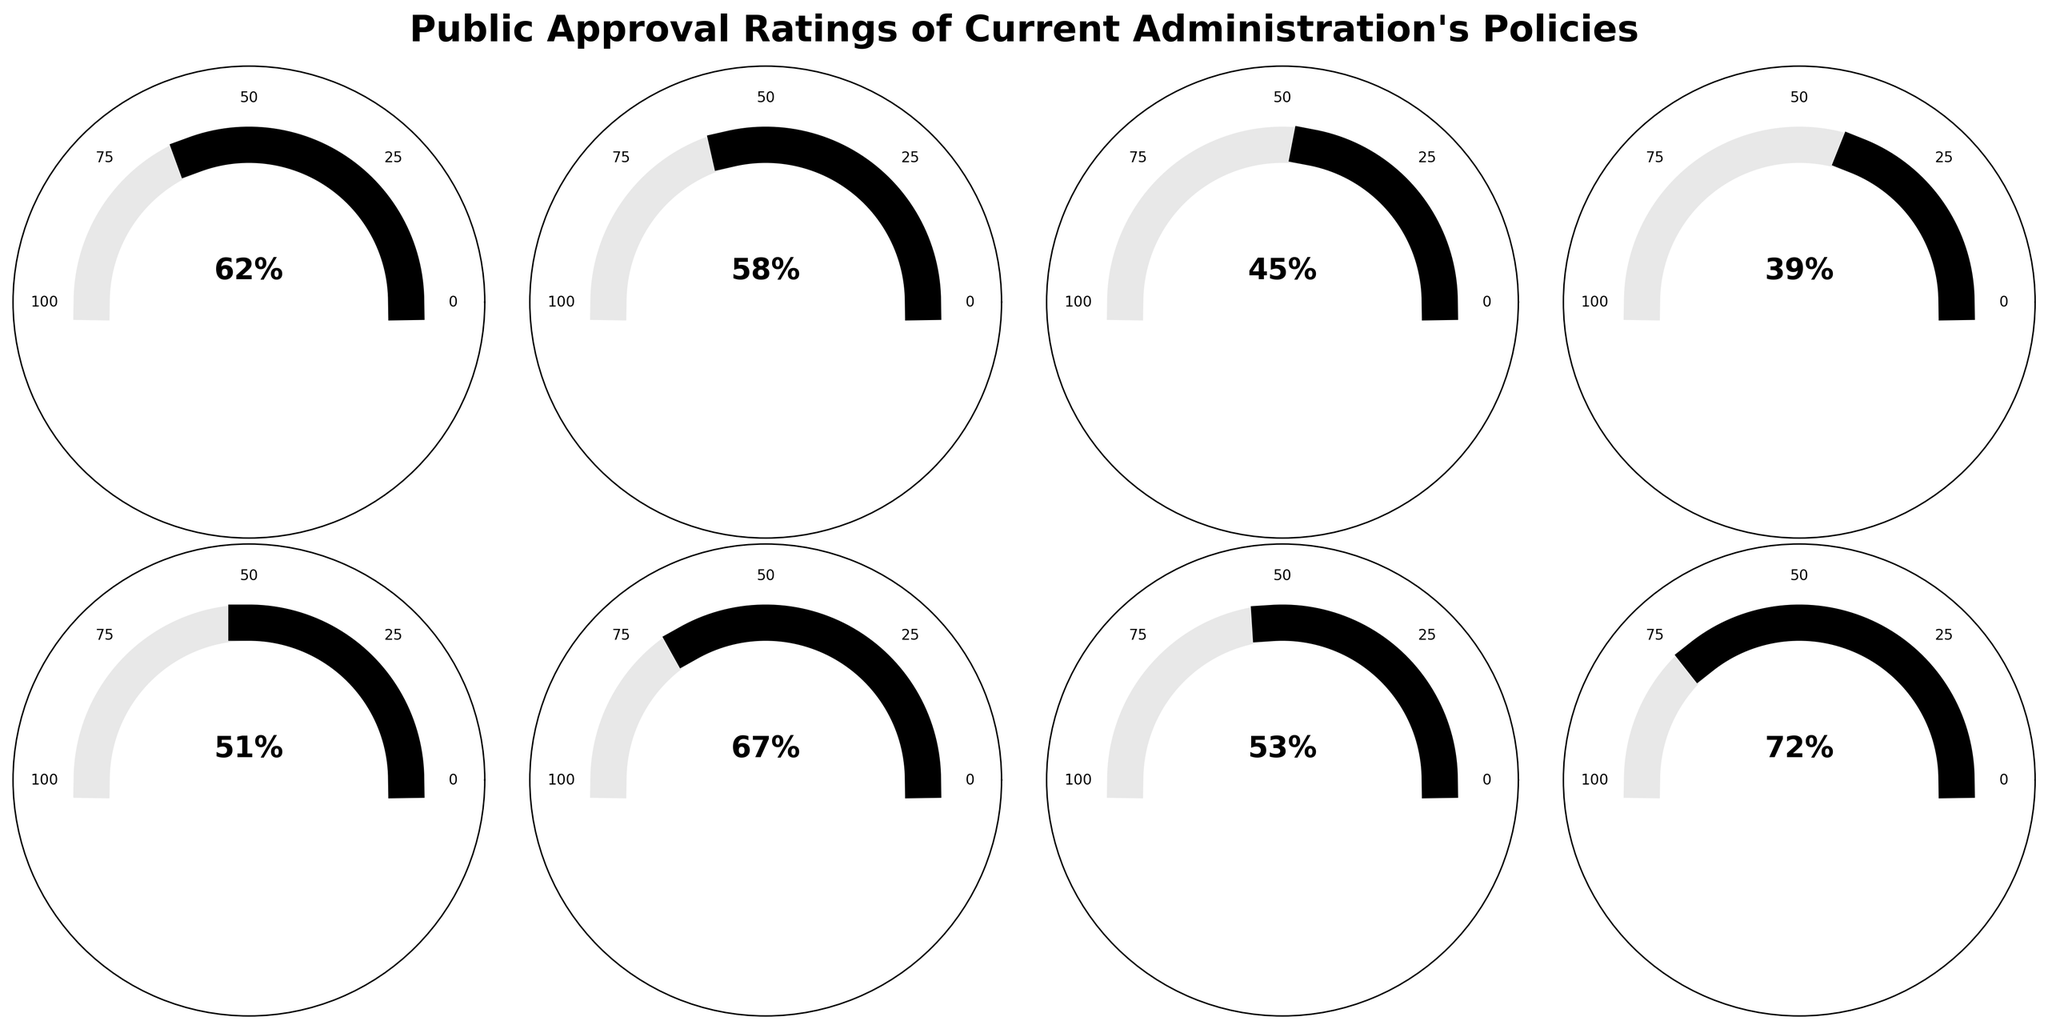What's the approval rating for Healthcare Reform? Locate the gauge labeled "Healthcare Reform" and read the approval rating displayed at the bottom half of the gauge.
Answer: 62% Which policy has the highest approval rating? Compare all the gauges and identify the one that extends the furthest to the right, indicating the highest rating.
Answer: Infrastructure Investment How many policies have an approval rating above 50%? Count the number of gauges with approval ratings displayed above the 50% mark.
Answer: 5 Which policy has a lower approval rating: Immigration Policy or Foreign Policy? Compare the lengths of the gauges for Immigration Policy and Foreign Policy and identify which one is shorter.
Answer: Immigration Policy What is the average approval rating for the policies shown? Sum all the approval ratings and divide by the number of policies. Calculation: (62 + 58 + 45 + 39 + 51 + 67 + 53 + 72) / 8 = 55.875
Answer: 55.875 How much higher is the approval rating for Criminal Justice Reform compared to Immigration Policy? Subtract the approval rating of Immigration Policy from the approval rating of Criminal Justice Reform. Calculation: 53 - 39 = 14
Answer: 14 Which policies have approval ratings between 50% and 70%? Identify the gauges with approval ratings that fall within the specified range.
Answer: Healthcare Reform, Climate Change Initiatives, Foreign Policy, Criminal Justice Reform, Education Reform Are there more policies with approval ratings below 50% or above 50%? Count the number of policies with approval ratings below and above 50%, then compare the counts.
Answer: Above 50% What is the combined approval rating of Economic Stimulus Package and Education Reform? Add the approval ratings of Economic Stimulus Package and Education Reform. Calculation: 45 + 67 = 112
Answer: 112 Which policy has an approval rating closest to the median value of the dataset? Arrange the approval ratings in ascending order and find the middle value, then identify the policy with that rating. Ordered ratings: 39, 45, 51, 53, 58, 62, 67, 72. Median is (53+58)/2=55.5, closest rating is 53 (Criminal Justice Reform).
Answer: Criminal Justice Reform 